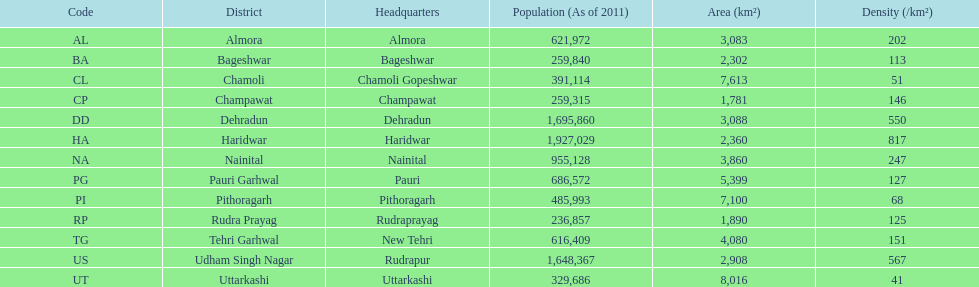What is the complete count of districts listed? 13. 